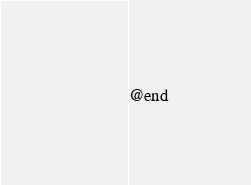<code> <loc_0><loc_0><loc_500><loc_500><_C_>
@end
</code> 